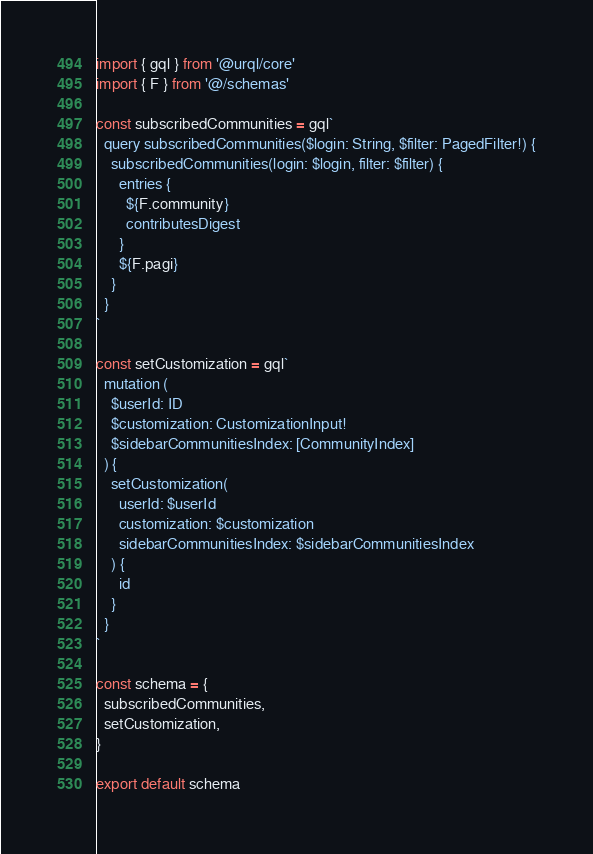Convert code to text. <code><loc_0><loc_0><loc_500><loc_500><_TypeScript_>import { gql } from '@urql/core'
import { F } from '@/schemas'

const subscribedCommunities = gql`
  query subscribedCommunities($login: String, $filter: PagedFilter!) {
    subscribedCommunities(login: $login, filter: $filter) {
      entries {
        ${F.community}
        contributesDigest
      }
      ${F.pagi}
    }
  }
`

const setCustomization = gql`
  mutation (
    $userId: ID
    $customization: CustomizationInput!
    $sidebarCommunitiesIndex: [CommunityIndex]
  ) {
    setCustomization(
      userId: $userId
      customization: $customization
      sidebarCommunitiesIndex: $sidebarCommunitiesIndex
    ) {
      id
    }
  }
`

const schema = {
  subscribedCommunities,
  setCustomization,
}

export default schema
</code> 